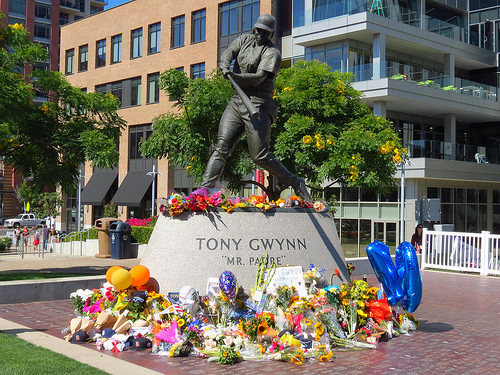<image>
Can you confirm if the building is behind the tree? Yes. From this viewpoint, the building is positioned behind the tree, with the tree partially or fully occluding the building. Is there a statue behind the tree? No. The statue is not behind the tree. From this viewpoint, the statue appears to be positioned elsewhere in the scene. 